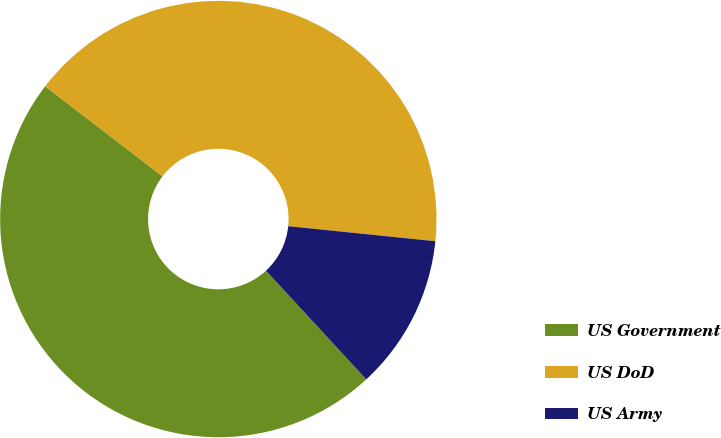Convert chart. <chart><loc_0><loc_0><loc_500><loc_500><pie_chart><fcel>US Government<fcel>US DoD<fcel>US Army<nl><fcel>47.27%<fcel>41.21%<fcel>11.52%<nl></chart> 